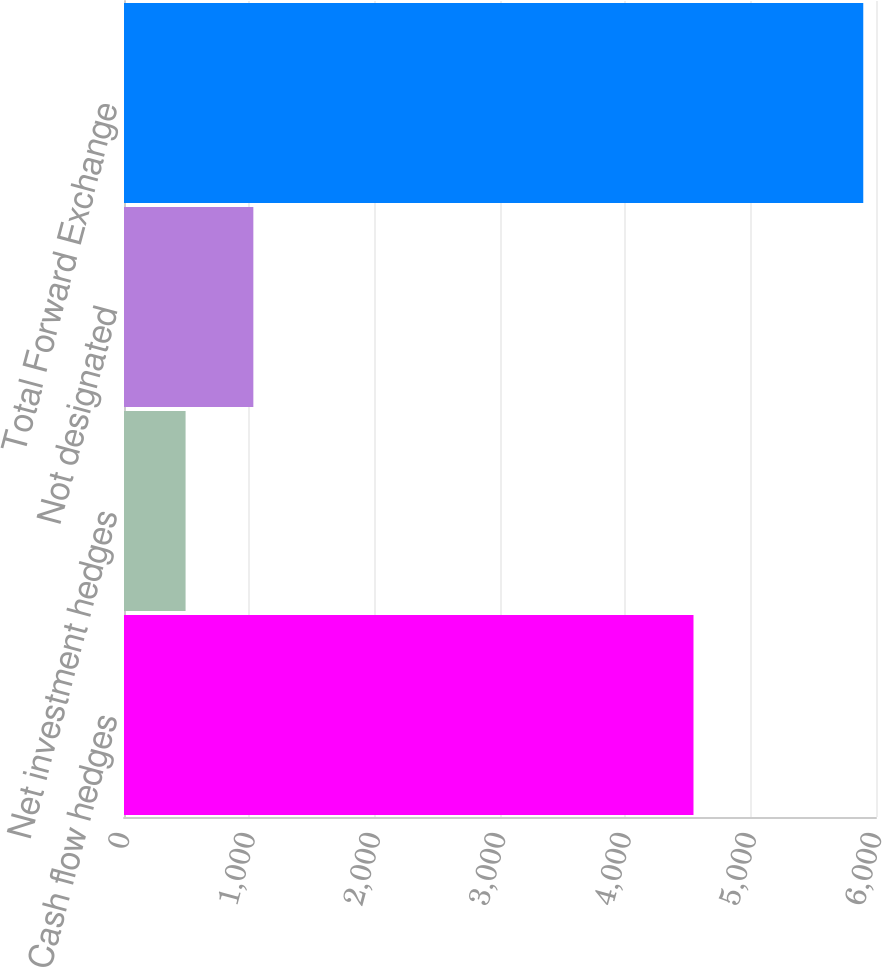<chart> <loc_0><loc_0><loc_500><loc_500><bar_chart><fcel>Cash flow hedges<fcel>Net investment hedges<fcel>Not designated<fcel>Total Forward Exchange<nl><fcel>4543.8<fcel>491.3<fcel>1032.01<fcel>5898.4<nl></chart> 